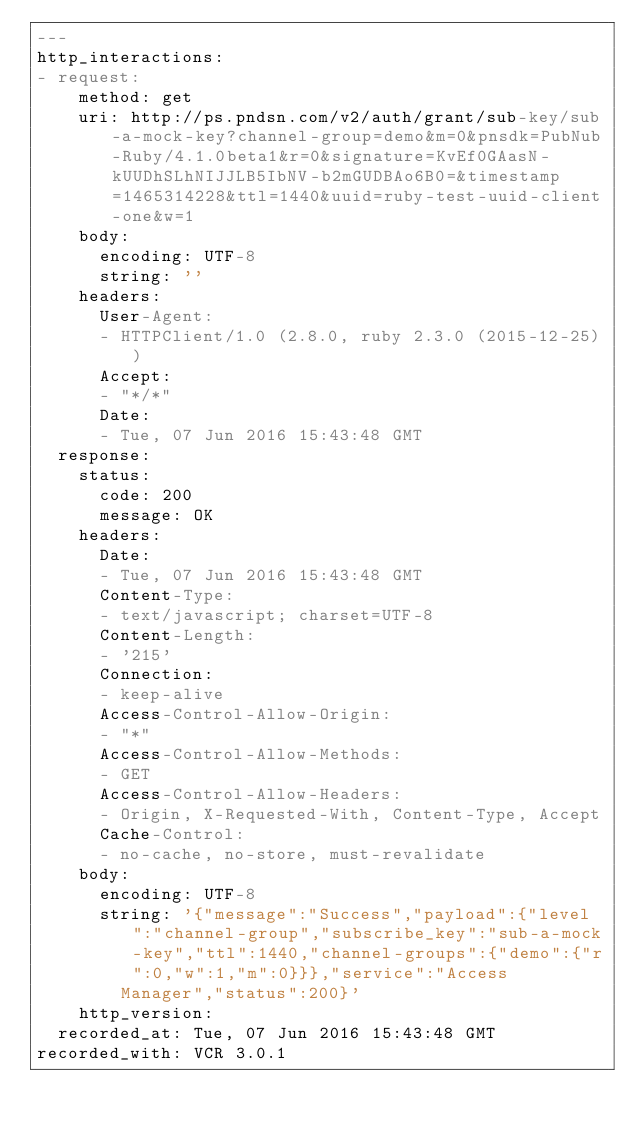<code> <loc_0><loc_0><loc_500><loc_500><_YAML_>---
http_interactions:
- request:
    method: get
    uri: http://ps.pndsn.com/v2/auth/grant/sub-key/sub-a-mock-key?channel-group=demo&m=0&pnsdk=PubNub-Ruby/4.1.0beta1&r=0&signature=KvEf0GAasN-kUUDhSLhNIJJLB5IbNV-b2mGUDBAo6B0=&timestamp=1465314228&ttl=1440&uuid=ruby-test-uuid-client-one&w=1
    body:
      encoding: UTF-8
      string: ''
    headers:
      User-Agent:
      - HTTPClient/1.0 (2.8.0, ruby 2.3.0 (2015-12-25))
      Accept:
      - "*/*"
      Date:
      - Tue, 07 Jun 2016 15:43:48 GMT
  response:
    status:
      code: 200
      message: OK
    headers:
      Date:
      - Tue, 07 Jun 2016 15:43:48 GMT
      Content-Type:
      - text/javascript; charset=UTF-8
      Content-Length:
      - '215'
      Connection:
      - keep-alive
      Access-Control-Allow-Origin:
      - "*"
      Access-Control-Allow-Methods:
      - GET
      Access-Control-Allow-Headers:
      - Origin, X-Requested-With, Content-Type, Accept
      Cache-Control:
      - no-cache, no-store, must-revalidate
    body:
      encoding: UTF-8
      string: '{"message":"Success","payload":{"level":"channel-group","subscribe_key":"sub-a-mock-key","ttl":1440,"channel-groups":{"demo":{"r":0,"w":1,"m":0}}},"service":"Access
        Manager","status":200}'
    http_version: 
  recorded_at: Tue, 07 Jun 2016 15:43:48 GMT
recorded_with: VCR 3.0.1
</code> 